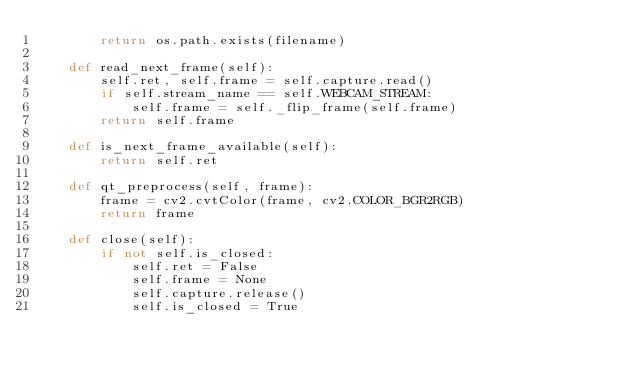Convert code to text. <code><loc_0><loc_0><loc_500><loc_500><_Python_>        return os.path.exists(filename)

    def read_next_frame(self):
        self.ret, self.frame = self.capture.read()
        if self.stream_name == self.WEBCAM_STREAM:
            self.frame = self._flip_frame(self.frame)
        return self.frame
    
    def is_next_frame_available(self):
        return self.ret

    def qt_preprocess(self, frame):
        frame = cv2.cvtColor(frame, cv2.COLOR_BGR2RGB)
        return frame
    
    def close(self):
        if not self.is_closed:
            self.ret = False
            self.frame = None
            self.capture.release()
            self.is_closed = True
</code> 